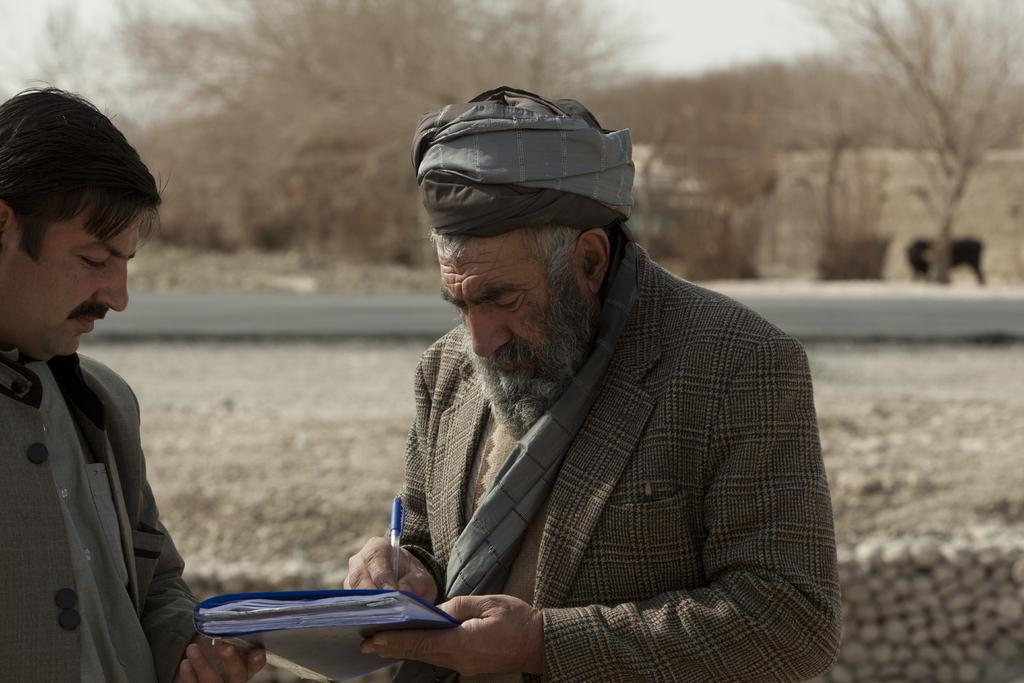What is the person in the image doing with the book? The person is holding a book and writing with a pen on it. Can you describe the other person in the image? There is another person standing beside the person holding the book. What can be seen in the background of the image? There are trees and an animal in the background of the image. What is the name of the insect that is flying around the person holding the book? There is no insect present in the image, so it is not possible to determine its name. 